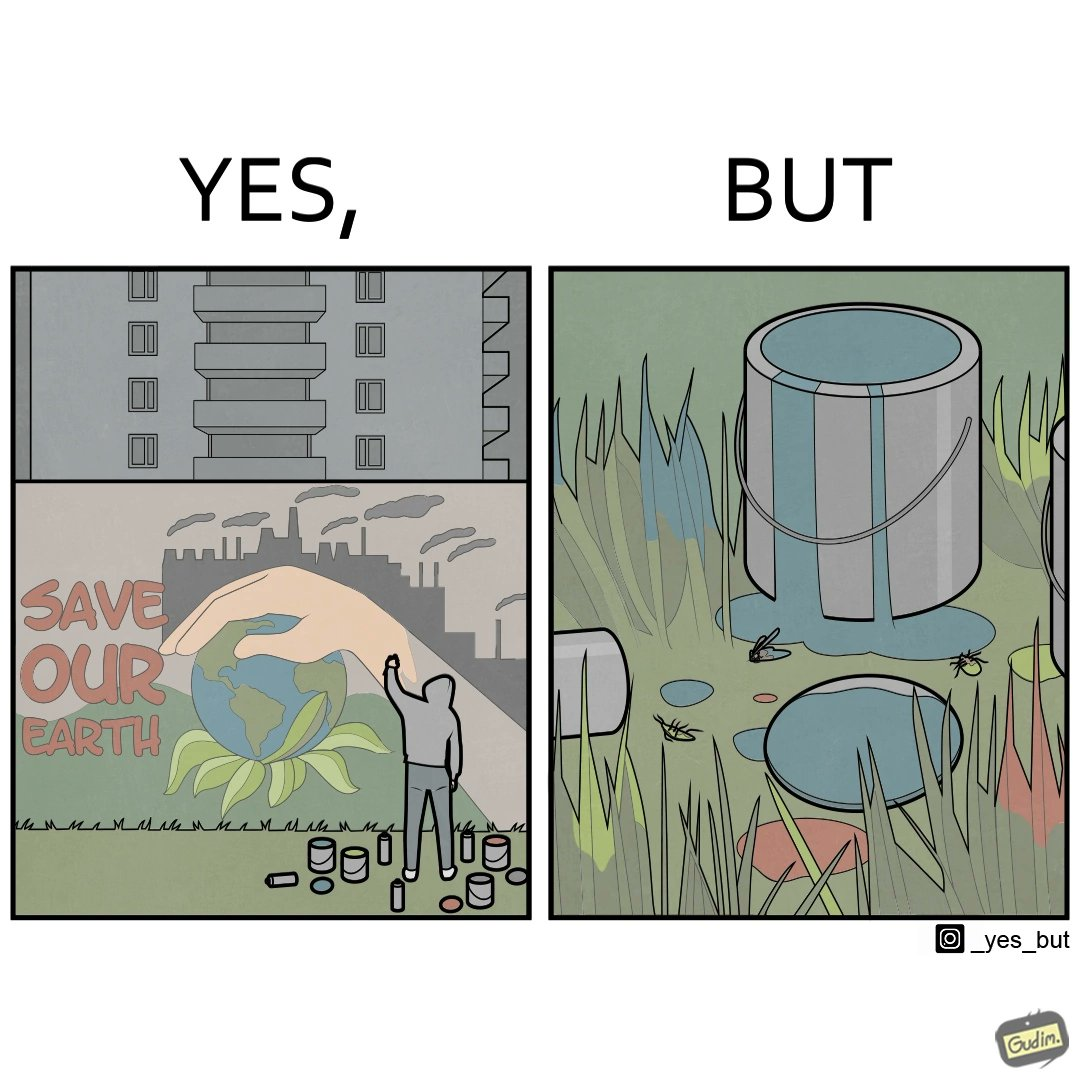What makes this image funny or satirical? The image is ironical, as the cans of paint used to make graffiti on the theme "Save the Earth" seems to be destroying the Earth when it overflows on the grass, as it is harmful for the flora and fauna, as can be seen from the dying insects. 